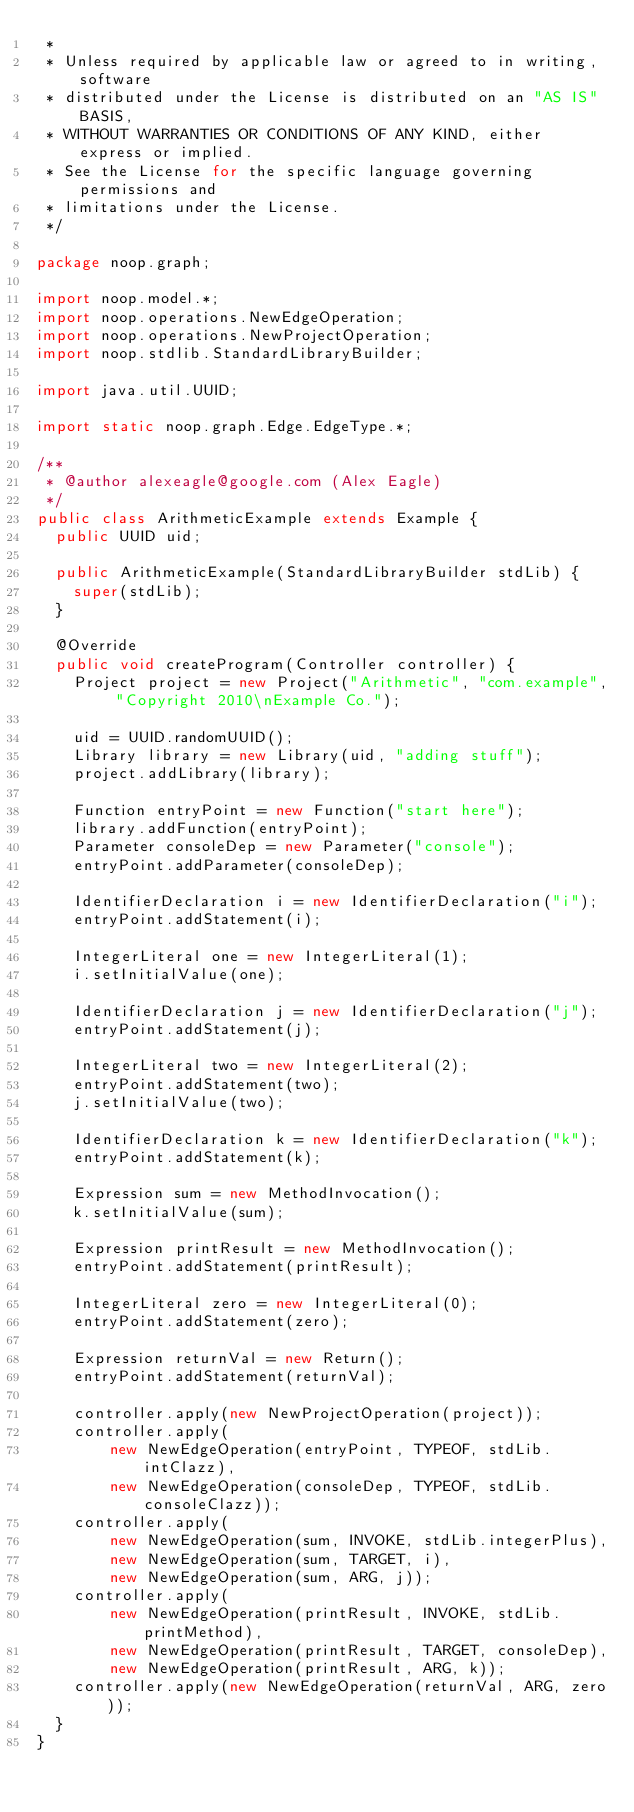<code> <loc_0><loc_0><loc_500><loc_500><_Java_> *
 * Unless required by applicable law or agreed to in writing, software
 * distributed under the License is distributed on an "AS IS" BASIS,
 * WITHOUT WARRANTIES OR CONDITIONS OF ANY KIND, either express or implied.
 * See the License for the specific language governing permissions and
 * limitations under the License.
 */

package noop.graph;

import noop.model.*;
import noop.operations.NewEdgeOperation;
import noop.operations.NewProjectOperation;
import noop.stdlib.StandardLibraryBuilder;

import java.util.UUID;

import static noop.graph.Edge.EdgeType.*;

/**
 * @author alexeagle@google.com (Alex Eagle)
 */
public class ArithmeticExample extends Example {
  public UUID uid;

  public ArithmeticExample(StandardLibraryBuilder stdLib) {
    super(stdLib);
  }

  @Override
  public void createProgram(Controller controller) {
    Project project = new Project("Arithmetic", "com.example", "Copyright 2010\nExample Co.");

    uid = UUID.randomUUID();
    Library library = new Library(uid, "adding stuff");
    project.addLibrary(library);

    Function entryPoint = new Function("start here");
    library.addFunction(entryPoint);
    Parameter consoleDep = new Parameter("console");
    entryPoint.addParameter(consoleDep);

    IdentifierDeclaration i = new IdentifierDeclaration("i");
    entryPoint.addStatement(i);

    IntegerLiteral one = new IntegerLiteral(1);
    i.setInitialValue(one);

    IdentifierDeclaration j = new IdentifierDeclaration("j");
    entryPoint.addStatement(j);

    IntegerLiteral two = new IntegerLiteral(2);
    entryPoint.addStatement(two);
    j.setInitialValue(two);

    IdentifierDeclaration k = new IdentifierDeclaration("k");
    entryPoint.addStatement(k);

    Expression sum = new MethodInvocation();
    k.setInitialValue(sum);

    Expression printResult = new MethodInvocation();
    entryPoint.addStatement(printResult);

    IntegerLiteral zero = new IntegerLiteral(0);
    entryPoint.addStatement(zero);

    Expression returnVal = new Return();
    entryPoint.addStatement(returnVal);
    
    controller.apply(new NewProjectOperation(project));
    controller.apply(
        new NewEdgeOperation(entryPoint, TYPEOF, stdLib.intClazz),
        new NewEdgeOperation(consoleDep, TYPEOF, stdLib.consoleClazz));
    controller.apply(
        new NewEdgeOperation(sum, INVOKE, stdLib.integerPlus),
        new NewEdgeOperation(sum, TARGET, i),
        new NewEdgeOperation(sum, ARG, j));
    controller.apply(
        new NewEdgeOperation(printResult, INVOKE, stdLib.printMethod),
        new NewEdgeOperation(printResult, TARGET, consoleDep),
        new NewEdgeOperation(printResult, ARG, k));
    controller.apply(new NewEdgeOperation(returnVal, ARG, zero));
  }
}
</code> 